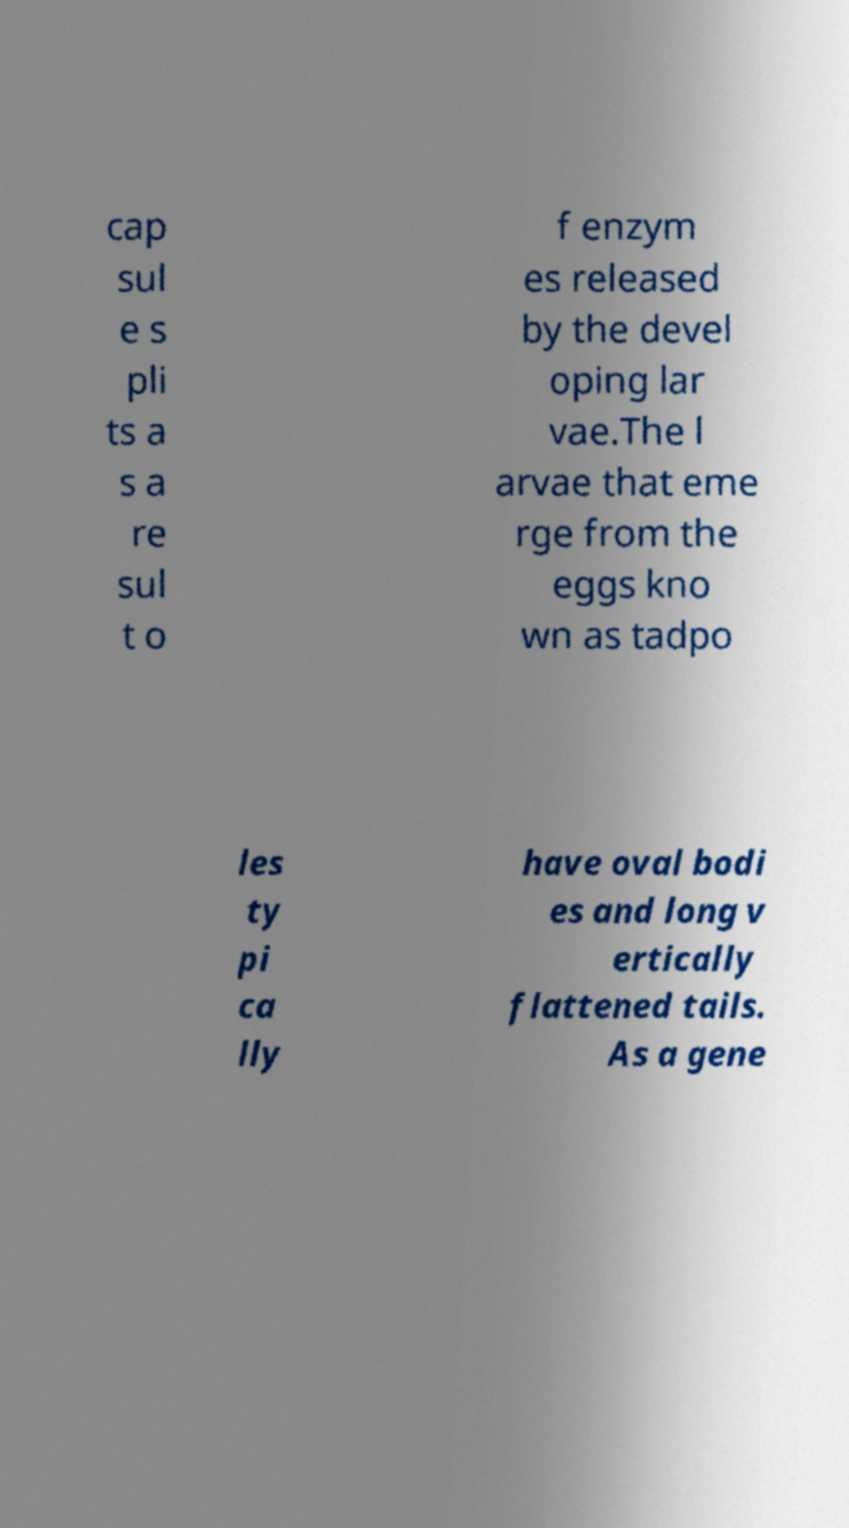What messages or text are displayed in this image? I need them in a readable, typed format. cap sul e s pli ts a s a re sul t o f enzym es released by the devel oping lar vae.The l arvae that eme rge from the eggs kno wn as tadpo les ty pi ca lly have oval bodi es and long v ertically flattened tails. As a gene 